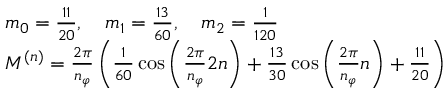Convert formula to latex. <formula><loc_0><loc_0><loc_500><loc_500>\begin{array} { r l } & { m _ { 0 } = \frac { 1 1 } { 2 0 } , \quad m _ { 1 } = \frac { 1 3 } { 6 0 } , \quad m _ { 2 } = \frac { 1 } { 1 2 0 } } \\ & { M ^ { ( n ) } = \frac { 2 \pi } { n _ { \varphi } } \left ( \frac { 1 } { 6 0 } \cos \left ( \frac { 2 \pi } { n _ { \varphi } } 2 n \right ) + \frac { 1 3 } { 3 0 } \cos \left ( \frac { 2 \pi } { n _ { \varphi } } n \right ) + \frac { 1 1 } { 2 0 } \right ) } \end{array}</formula> 